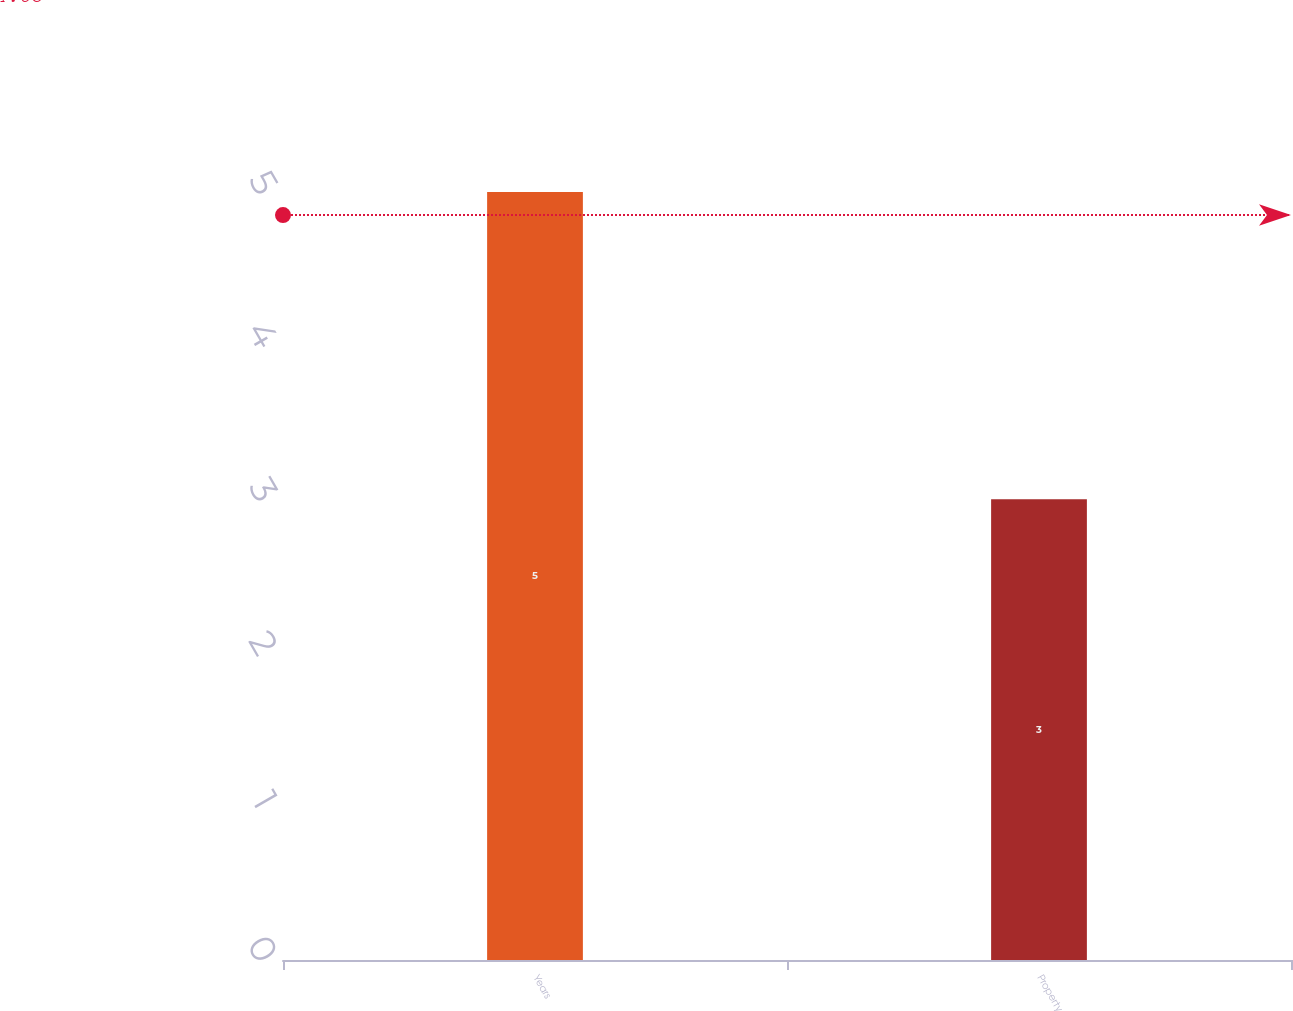Convert chart. <chart><loc_0><loc_0><loc_500><loc_500><bar_chart><fcel>Years<fcel>Property<nl><fcel>5<fcel>3<nl></chart> 